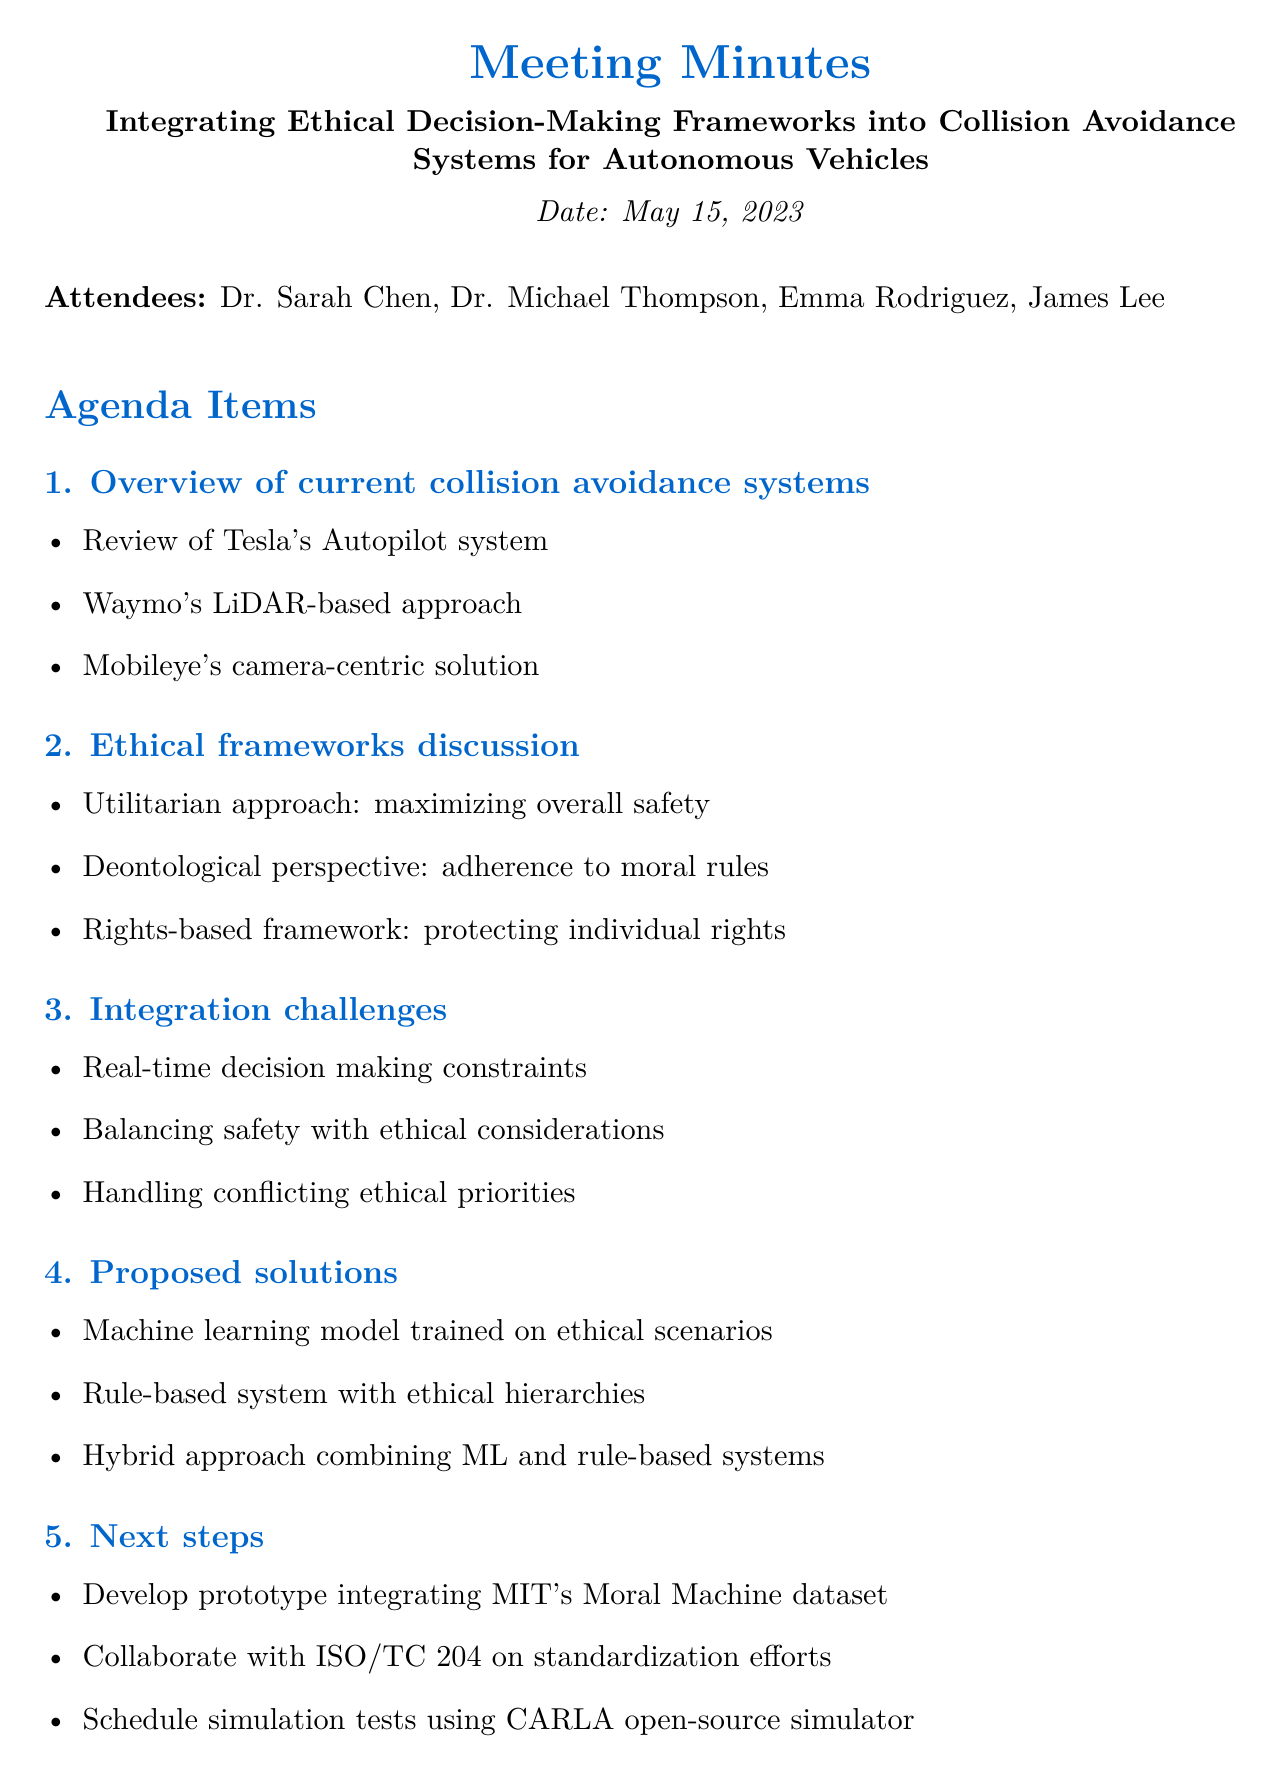What is the date of the meeting? The date of the meeting is explicitly stated in the document, which is May 15, 2023.
Answer: May 15, 2023 Who is the lead robotics engineer? The document lists the attendees and identifies Dr. Sarah Chen as the Lead Robotics Engineer.
Answer: Dr. Sarah Chen What is the deadline for creating the ethical scenario database? The document specifies deadlines for action items, stating that the ethical scenario database is due by June 15, 2023.
Answer: June 15, 2023 What ethical approach focuses on maximizing overall safety? The document outlines several ethical frameworks, indicating that the utilitarian approach aims at maximizing overall safety.
Answer: Utilitarian approach Which simulation environment is scheduled for setup? The action items include setting up the CARLA simulation environment, as mentioned under the next steps.
Answer: CARLA simulation environment What type of solutions were proposed for integration challenges? The document details proposed solutions, listing a hybrid approach that combines machine learning and rule-based systems.
Answer: Hybrid approach combining ML and rule-based systems Which framework is concerned with protecting individual rights? Among the ethical frameworks discussed, the rights-based framework is particularly focused on protecting individual rights.
Answer: Rights-based framework Who is responsible for developing the initial machine learning model prototype? The responsibilities for action items include Emma Rodriguez being assigned to develop the initial ML model prototype.
Answer: Emma Rodriguez 